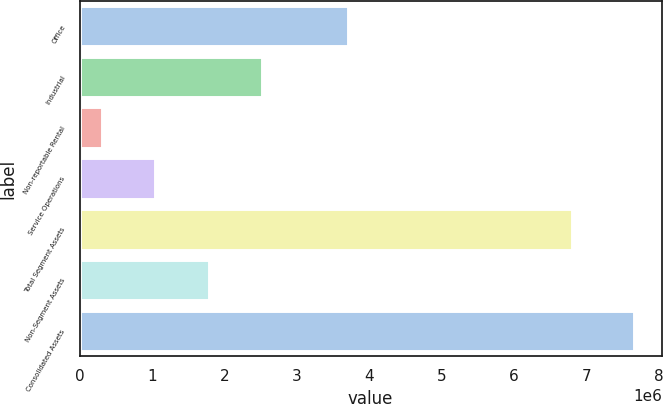Convert chart to OTSL. <chart><loc_0><loc_0><loc_500><loc_500><bar_chart><fcel>Office<fcel>Industrial<fcel>Non-reportable Rental<fcel>Service Operations<fcel>Total Segment Assets<fcel>Non-Segment Assets<fcel>Consolidated Assets<nl><fcel>3.70593e+06<fcel>2.51717e+06<fcel>312246<fcel>1.04722e+06<fcel>6.80771e+06<fcel>1.78219e+06<fcel>7.66198e+06<nl></chart> 